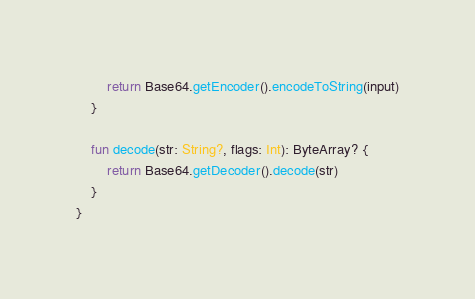<code> <loc_0><loc_0><loc_500><loc_500><_Kotlin_>        return Base64.getEncoder().encodeToString(input)
    }

    fun decode(str: String?, flags: Int): ByteArray? {
        return Base64.getDecoder().decode(str)
    }
}</code> 